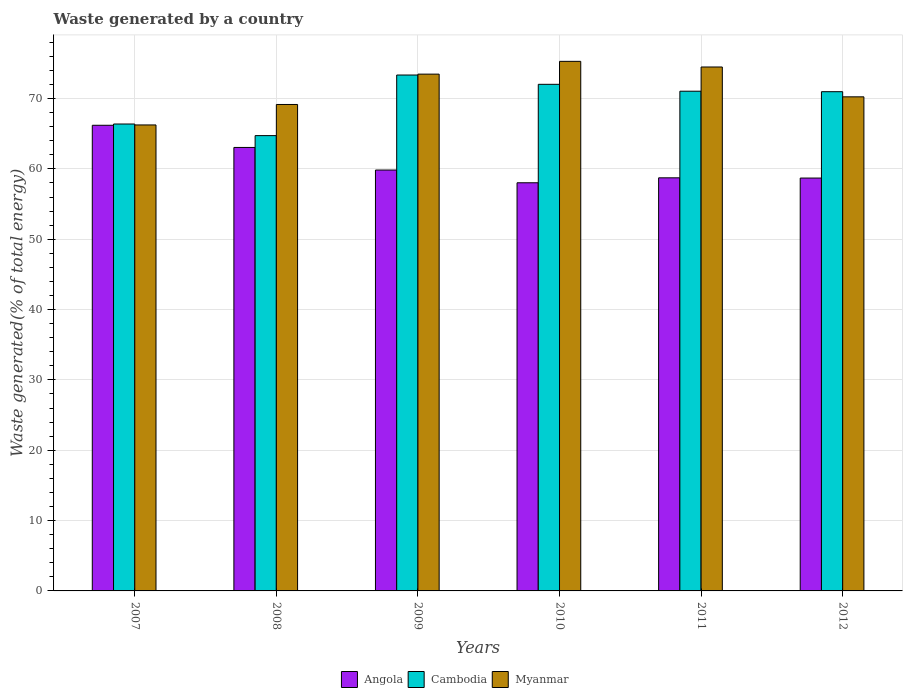Are the number of bars per tick equal to the number of legend labels?
Offer a very short reply. Yes. How many bars are there on the 3rd tick from the left?
Your response must be concise. 3. How many bars are there on the 3rd tick from the right?
Your answer should be compact. 3. What is the total waste generated in Angola in 2009?
Your answer should be very brief. 59.84. Across all years, what is the maximum total waste generated in Cambodia?
Ensure brevity in your answer.  73.35. Across all years, what is the minimum total waste generated in Angola?
Your answer should be very brief. 58.03. What is the total total waste generated in Angola in the graph?
Your answer should be very brief. 364.56. What is the difference between the total waste generated in Angola in 2007 and that in 2011?
Offer a very short reply. 7.47. What is the difference between the total waste generated in Myanmar in 2010 and the total waste generated in Angola in 2012?
Offer a very short reply. 16.59. What is the average total waste generated in Myanmar per year?
Provide a succinct answer. 71.49. In the year 2011, what is the difference between the total waste generated in Cambodia and total waste generated in Angola?
Your answer should be very brief. 12.31. What is the ratio of the total waste generated in Cambodia in 2010 to that in 2012?
Give a very brief answer. 1.01. What is the difference between the highest and the second highest total waste generated in Cambodia?
Your response must be concise. 1.32. What is the difference between the highest and the lowest total waste generated in Cambodia?
Your response must be concise. 8.62. In how many years, is the total waste generated in Angola greater than the average total waste generated in Angola taken over all years?
Provide a succinct answer. 2. What does the 3rd bar from the left in 2009 represents?
Offer a very short reply. Myanmar. What does the 3rd bar from the right in 2009 represents?
Offer a terse response. Angola. Is it the case that in every year, the sum of the total waste generated in Myanmar and total waste generated in Angola is greater than the total waste generated in Cambodia?
Make the answer very short. Yes. How many bars are there?
Offer a very short reply. 18. What is the difference between two consecutive major ticks on the Y-axis?
Keep it short and to the point. 10. Are the values on the major ticks of Y-axis written in scientific E-notation?
Your response must be concise. No. Does the graph contain grids?
Make the answer very short. Yes. What is the title of the graph?
Make the answer very short. Waste generated by a country. What is the label or title of the Y-axis?
Ensure brevity in your answer.  Waste generated(% of total energy). What is the Waste generated(% of total energy) in Angola in 2007?
Make the answer very short. 66.2. What is the Waste generated(% of total energy) of Cambodia in 2007?
Give a very brief answer. 66.38. What is the Waste generated(% of total energy) of Myanmar in 2007?
Make the answer very short. 66.25. What is the Waste generated(% of total energy) of Angola in 2008?
Offer a very short reply. 63.05. What is the Waste generated(% of total energy) in Cambodia in 2008?
Your answer should be compact. 64.73. What is the Waste generated(% of total energy) in Myanmar in 2008?
Give a very brief answer. 69.16. What is the Waste generated(% of total energy) in Angola in 2009?
Keep it short and to the point. 59.84. What is the Waste generated(% of total energy) in Cambodia in 2009?
Ensure brevity in your answer.  73.35. What is the Waste generated(% of total energy) in Myanmar in 2009?
Provide a succinct answer. 73.47. What is the Waste generated(% of total energy) of Angola in 2010?
Ensure brevity in your answer.  58.03. What is the Waste generated(% of total energy) of Cambodia in 2010?
Make the answer very short. 72.03. What is the Waste generated(% of total energy) in Myanmar in 2010?
Make the answer very short. 75.29. What is the Waste generated(% of total energy) in Angola in 2011?
Provide a succinct answer. 58.73. What is the Waste generated(% of total energy) of Cambodia in 2011?
Your response must be concise. 71.05. What is the Waste generated(% of total energy) of Myanmar in 2011?
Ensure brevity in your answer.  74.49. What is the Waste generated(% of total energy) in Angola in 2012?
Your answer should be very brief. 58.7. What is the Waste generated(% of total energy) of Cambodia in 2012?
Provide a short and direct response. 70.98. What is the Waste generated(% of total energy) of Myanmar in 2012?
Your answer should be very brief. 70.25. Across all years, what is the maximum Waste generated(% of total energy) of Angola?
Provide a short and direct response. 66.2. Across all years, what is the maximum Waste generated(% of total energy) in Cambodia?
Provide a succinct answer. 73.35. Across all years, what is the maximum Waste generated(% of total energy) of Myanmar?
Keep it short and to the point. 75.29. Across all years, what is the minimum Waste generated(% of total energy) of Angola?
Your answer should be very brief. 58.03. Across all years, what is the minimum Waste generated(% of total energy) of Cambodia?
Make the answer very short. 64.73. Across all years, what is the minimum Waste generated(% of total energy) of Myanmar?
Keep it short and to the point. 66.25. What is the total Waste generated(% of total energy) of Angola in the graph?
Your answer should be compact. 364.56. What is the total Waste generated(% of total energy) in Cambodia in the graph?
Your response must be concise. 418.52. What is the total Waste generated(% of total energy) in Myanmar in the graph?
Offer a terse response. 428.91. What is the difference between the Waste generated(% of total energy) in Angola in 2007 and that in 2008?
Make the answer very short. 3.15. What is the difference between the Waste generated(% of total energy) of Cambodia in 2007 and that in 2008?
Make the answer very short. 1.65. What is the difference between the Waste generated(% of total energy) of Myanmar in 2007 and that in 2008?
Ensure brevity in your answer.  -2.91. What is the difference between the Waste generated(% of total energy) of Angola in 2007 and that in 2009?
Provide a succinct answer. 6.37. What is the difference between the Waste generated(% of total energy) of Cambodia in 2007 and that in 2009?
Give a very brief answer. -6.96. What is the difference between the Waste generated(% of total energy) in Myanmar in 2007 and that in 2009?
Give a very brief answer. -7.22. What is the difference between the Waste generated(% of total energy) of Angola in 2007 and that in 2010?
Give a very brief answer. 8.18. What is the difference between the Waste generated(% of total energy) of Cambodia in 2007 and that in 2010?
Your answer should be compact. -5.64. What is the difference between the Waste generated(% of total energy) of Myanmar in 2007 and that in 2010?
Your answer should be compact. -9.04. What is the difference between the Waste generated(% of total energy) of Angola in 2007 and that in 2011?
Provide a succinct answer. 7.47. What is the difference between the Waste generated(% of total energy) in Cambodia in 2007 and that in 2011?
Provide a succinct answer. -4.66. What is the difference between the Waste generated(% of total energy) of Myanmar in 2007 and that in 2011?
Your response must be concise. -8.24. What is the difference between the Waste generated(% of total energy) of Angola in 2007 and that in 2012?
Offer a very short reply. 7.51. What is the difference between the Waste generated(% of total energy) in Cambodia in 2007 and that in 2012?
Ensure brevity in your answer.  -4.59. What is the difference between the Waste generated(% of total energy) of Myanmar in 2007 and that in 2012?
Offer a very short reply. -4. What is the difference between the Waste generated(% of total energy) in Angola in 2008 and that in 2009?
Ensure brevity in your answer.  3.21. What is the difference between the Waste generated(% of total energy) of Cambodia in 2008 and that in 2009?
Make the answer very short. -8.62. What is the difference between the Waste generated(% of total energy) of Myanmar in 2008 and that in 2009?
Give a very brief answer. -4.31. What is the difference between the Waste generated(% of total energy) of Angola in 2008 and that in 2010?
Your answer should be compact. 5.02. What is the difference between the Waste generated(% of total energy) in Cambodia in 2008 and that in 2010?
Make the answer very short. -7.3. What is the difference between the Waste generated(% of total energy) in Myanmar in 2008 and that in 2010?
Keep it short and to the point. -6.13. What is the difference between the Waste generated(% of total energy) of Angola in 2008 and that in 2011?
Provide a short and direct response. 4.32. What is the difference between the Waste generated(% of total energy) in Cambodia in 2008 and that in 2011?
Offer a very short reply. -6.32. What is the difference between the Waste generated(% of total energy) of Myanmar in 2008 and that in 2011?
Provide a short and direct response. -5.33. What is the difference between the Waste generated(% of total energy) of Angola in 2008 and that in 2012?
Give a very brief answer. 4.35. What is the difference between the Waste generated(% of total energy) in Cambodia in 2008 and that in 2012?
Your answer should be compact. -6.25. What is the difference between the Waste generated(% of total energy) in Myanmar in 2008 and that in 2012?
Offer a very short reply. -1.09. What is the difference between the Waste generated(% of total energy) in Angola in 2009 and that in 2010?
Give a very brief answer. 1.81. What is the difference between the Waste generated(% of total energy) of Cambodia in 2009 and that in 2010?
Offer a very short reply. 1.32. What is the difference between the Waste generated(% of total energy) in Myanmar in 2009 and that in 2010?
Your answer should be compact. -1.82. What is the difference between the Waste generated(% of total energy) of Angola in 2009 and that in 2011?
Provide a succinct answer. 1.11. What is the difference between the Waste generated(% of total energy) of Cambodia in 2009 and that in 2011?
Provide a short and direct response. 2.3. What is the difference between the Waste generated(% of total energy) in Myanmar in 2009 and that in 2011?
Give a very brief answer. -1.01. What is the difference between the Waste generated(% of total energy) of Angola in 2009 and that in 2012?
Make the answer very short. 1.14. What is the difference between the Waste generated(% of total energy) in Cambodia in 2009 and that in 2012?
Provide a succinct answer. 2.37. What is the difference between the Waste generated(% of total energy) in Myanmar in 2009 and that in 2012?
Provide a succinct answer. 3.23. What is the difference between the Waste generated(% of total energy) in Angola in 2010 and that in 2011?
Your response must be concise. -0.7. What is the difference between the Waste generated(% of total energy) of Cambodia in 2010 and that in 2011?
Ensure brevity in your answer.  0.98. What is the difference between the Waste generated(% of total energy) in Myanmar in 2010 and that in 2011?
Make the answer very short. 0.8. What is the difference between the Waste generated(% of total energy) in Angola in 2010 and that in 2012?
Provide a short and direct response. -0.67. What is the difference between the Waste generated(% of total energy) in Cambodia in 2010 and that in 2012?
Provide a succinct answer. 1.05. What is the difference between the Waste generated(% of total energy) in Myanmar in 2010 and that in 2012?
Your answer should be very brief. 5.05. What is the difference between the Waste generated(% of total energy) in Angola in 2011 and that in 2012?
Ensure brevity in your answer.  0.03. What is the difference between the Waste generated(% of total energy) in Cambodia in 2011 and that in 2012?
Ensure brevity in your answer.  0.07. What is the difference between the Waste generated(% of total energy) of Myanmar in 2011 and that in 2012?
Your response must be concise. 4.24. What is the difference between the Waste generated(% of total energy) of Angola in 2007 and the Waste generated(% of total energy) of Cambodia in 2008?
Your answer should be compact. 1.47. What is the difference between the Waste generated(% of total energy) of Angola in 2007 and the Waste generated(% of total energy) of Myanmar in 2008?
Make the answer very short. -2.96. What is the difference between the Waste generated(% of total energy) of Cambodia in 2007 and the Waste generated(% of total energy) of Myanmar in 2008?
Make the answer very short. -2.78. What is the difference between the Waste generated(% of total energy) of Angola in 2007 and the Waste generated(% of total energy) of Cambodia in 2009?
Give a very brief answer. -7.14. What is the difference between the Waste generated(% of total energy) in Angola in 2007 and the Waste generated(% of total energy) in Myanmar in 2009?
Your response must be concise. -7.27. What is the difference between the Waste generated(% of total energy) in Cambodia in 2007 and the Waste generated(% of total energy) in Myanmar in 2009?
Your response must be concise. -7.09. What is the difference between the Waste generated(% of total energy) of Angola in 2007 and the Waste generated(% of total energy) of Cambodia in 2010?
Your answer should be very brief. -5.82. What is the difference between the Waste generated(% of total energy) in Angola in 2007 and the Waste generated(% of total energy) in Myanmar in 2010?
Your answer should be very brief. -9.09. What is the difference between the Waste generated(% of total energy) in Cambodia in 2007 and the Waste generated(% of total energy) in Myanmar in 2010?
Give a very brief answer. -8.91. What is the difference between the Waste generated(% of total energy) in Angola in 2007 and the Waste generated(% of total energy) in Cambodia in 2011?
Make the answer very short. -4.84. What is the difference between the Waste generated(% of total energy) in Angola in 2007 and the Waste generated(% of total energy) in Myanmar in 2011?
Give a very brief answer. -8.28. What is the difference between the Waste generated(% of total energy) of Cambodia in 2007 and the Waste generated(% of total energy) of Myanmar in 2011?
Provide a short and direct response. -8.11. What is the difference between the Waste generated(% of total energy) in Angola in 2007 and the Waste generated(% of total energy) in Cambodia in 2012?
Offer a very short reply. -4.77. What is the difference between the Waste generated(% of total energy) in Angola in 2007 and the Waste generated(% of total energy) in Myanmar in 2012?
Offer a terse response. -4.04. What is the difference between the Waste generated(% of total energy) in Cambodia in 2007 and the Waste generated(% of total energy) in Myanmar in 2012?
Offer a very short reply. -3.86. What is the difference between the Waste generated(% of total energy) in Angola in 2008 and the Waste generated(% of total energy) in Cambodia in 2009?
Give a very brief answer. -10.3. What is the difference between the Waste generated(% of total energy) in Angola in 2008 and the Waste generated(% of total energy) in Myanmar in 2009?
Ensure brevity in your answer.  -10.42. What is the difference between the Waste generated(% of total energy) of Cambodia in 2008 and the Waste generated(% of total energy) of Myanmar in 2009?
Provide a succinct answer. -8.74. What is the difference between the Waste generated(% of total energy) in Angola in 2008 and the Waste generated(% of total energy) in Cambodia in 2010?
Offer a very short reply. -8.98. What is the difference between the Waste generated(% of total energy) of Angola in 2008 and the Waste generated(% of total energy) of Myanmar in 2010?
Ensure brevity in your answer.  -12.24. What is the difference between the Waste generated(% of total energy) of Cambodia in 2008 and the Waste generated(% of total energy) of Myanmar in 2010?
Offer a terse response. -10.56. What is the difference between the Waste generated(% of total energy) in Angola in 2008 and the Waste generated(% of total energy) in Cambodia in 2011?
Provide a short and direct response. -8. What is the difference between the Waste generated(% of total energy) of Angola in 2008 and the Waste generated(% of total energy) of Myanmar in 2011?
Keep it short and to the point. -11.44. What is the difference between the Waste generated(% of total energy) of Cambodia in 2008 and the Waste generated(% of total energy) of Myanmar in 2011?
Give a very brief answer. -9.76. What is the difference between the Waste generated(% of total energy) in Angola in 2008 and the Waste generated(% of total energy) in Cambodia in 2012?
Ensure brevity in your answer.  -7.93. What is the difference between the Waste generated(% of total energy) of Angola in 2008 and the Waste generated(% of total energy) of Myanmar in 2012?
Your response must be concise. -7.2. What is the difference between the Waste generated(% of total energy) in Cambodia in 2008 and the Waste generated(% of total energy) in Myanmar in 2012?
Your response must be concise. -5.51. What is the difference between the Waste generated(% of total energy) of Angola in 2009 and the Waste generated(% of total energy) of Cambodia in 2010?
Provide a short and direct response. -12.19. What is the difference between the Waste generated(% of total energy) in Angola in 2009 and the Waste generated(% of total energy) in Myanmar in 2010?
Provide a succinct answer. -15.45. What is the difference between the Waste generated(% of total energy) in Cambodia in 2009 and the Waste generated(% of total energy) in Myanmar in 2010?
Offer a very short reply. -1.94. What is the difference between the Waste generated(% of total energy) of Angola in 2009 and the Waste generated(% of total energy) of Cambodia in 2011?
Provide a short and direct response. -11.21. What is the difference between the Waste generated(% of total energy) in Angola in 2009 and the Waste generated(% of total energy) in Myanmar in 2011?
Keep it short and to the point. -14.65. What is the difference between the Waste generated(% of total energy) in Cambodia in 2009 and the Waste generated(% of total energy) in Myanmar in 2011?
Ensure brevity in your answer.  -1.14. What is the difference between the Waste generated(% of total energy) of Angola in 2009 and the Waste generated(% of total energy) of Cambodia in 2012?
Your answer should be compact. -11.14. What is the difference between the Waste generated(% of total energy) of Angola in 2009 and the Waste generated(% of total energy) of Myanmar in 2012?
Give a very brief answer. -10.41. What is the difference between the Waste generated(% of total energy) in Cambodia in 2009 and the Waste generated(% of total energy) in Myanmar in 2012?
Keep it short and to the point. 3.1. What is the difference between the Waste generated(% of total energy) in Angola in 2010 and the Waste generated(% of total energy) in Cambodia in 2011?
Provide a succinct answer. -13.02. What is the difference between the Waste generated(% of total energy) in Angola in 2010 and the Waste generated(% of total energy) in Myanmar in 2011?
Make the answer very short. -16.46. What is the difference between the Waste generated(% of total energy) in Cambodia in 2010 and the Waste generated(% of total energy) in Myanmar in 2011?
Your answer should be very brief. -2.46. What is the difference between the Waste generated(% of total energy) in Angola in 2010 and the Waste generated(% of total energy) in Cambodia in 2012?
Your response must be concise. -12.95. What is the difference between the Waste generated(% of total energy) of Angola in 2010 and the Waste generated(% of total energy) of Myanmar in 2012?
Make the answer very short. -12.22. What is the difference between the Waste generated(% of total energy) of Cambodia in 2010 and the Waste generated(% of total energy) of Myanmar in 2012?
Your response must be concise. 1.78. What is the difference between the Waste generated(% of total energy) of Angola in 2011 and the Waste generated(% of total energy) of Cambodia in 2012?
Offer a terse response. -12.25. What is the difference between the Waste generated(% of total energy) of Angola in 2011 and the Waste generated(% of total energy) of Myanmar in 2012?
Provide a succinct answer. -11.51. What is the difference between the Waste generated(% of total energy) in Cambodia in 2011 and the Waste generated(% of total energy) in Myanmar in 2012?
Your answer should be compact. 0.8. What is the average Waste generated(% of total energy) of Angola per year?
Ensure brevity in your answer.  60.76. What is the average Waste generated(% of total energy) of Cambodia per year?
Make the answer very short. 69.75. What is the average Waste generated(% of total energy) of Myanmar per year?
Make the answer very short. 71.49. In the year 2007, what is the difference between the Waste generated(% of total energy) in Angola and Waste generated(% of total energy) in Cambodia?
Your answer should be very brief. -0.18. In the year 2007, what is the difference between the Waste generated(% of total energy) of Angola and Waste generated(% of total energy) of Myanmar?
Offer a terse response. -0.05. In the year 2007, what is the difference between the Waste generated(% of total energy) in Cambodia and Waste generated(% of total energy) in Myanmar?
Keep it short and to the point. 0.13. In the year 2008, what is the difference between the Waste generated(% of total energy) in Angola and Waste generated(% of total energy) in Cambodia?
Give a very brief answer. -1.68. In the year 2008, what is the difference between the Waste generated(% of total energy) of Angola and Waste generated(% of total energy) of Myanmar?
Ensure brevity in your answer.  -6.11. In the year 2008, what is the difference between the Waste generated(% of total energy) of Cambodia and Waste generated(% of total energy) of Myanmar?
Keep it short and to the point. -4.43. In the year 2009, what is the difference between the Waste generated(% of total energy) in Angola and Waste generated(% of total energy) in Cambodia?
Give a very brief answer. -13.51. In the year 2009, what is the difference between the Waste generated(% of total energy) in Angola and Waste generated(% of total energy) in Myanmar?
Make the answer very short. -13.64. In the year 2009, what is the difference between the Waste generated(% of total energy) of Cambodia and Waste generated(% of total energy) of Myanmar?
Your answer should be compact. -0.13. In the year 2010, what is the difference between the Waste generated(% of total energy) in Angola and Waste generated(% of total energy) in Cambodia?
Provide a succinct answer. -14. In the year 2010, what is the difference between the Waste generated(% of total energy) in Angola and Waste generated(% of total energy) in Myanmar?
Your answer should be very brief. -17.26. In the year 2010, what is the difference between the Waste generated(% of total energy) in Cambodia and Waste generated(% of total energy) in Myanmar?
Give a very brief answer. -3.26. In the year 2011, what is the difference between the Waste generated(% of total energy) in Angola and Waste generated(% of total energy) in Cambodia?
Make the answer very short. -12.31. In the year 2011, what is the difference between the Waste generated(% of total energy) of Angola and Waste generated(% of total energy) of Myanmar?
Provide a short and direct response. -15.76. In the year 2011, what is the difference between the Waste generated(% of total energy) in Cambodia and Waste generated(% of total energy) in Myanmar?
Give a very brief answer. -3.44. In the year 2012, what is the difference between the Waste generated(% of total energy) of Angola and Waste generated(% of total energy) of Cambodia?
Offer a very short reply. -12.28. In the year 2012, what is the difference between the Waste generated(% of total energy) of Angola and Waste generated(% of total energy) of Myanmar?
Offer a terse response. -11.55. In the year 2012, what is the difference between the Waste generated(% of total energy) of Cambodia and Waste generated(% of total energy) of Myanmar?
Keep it short and to the point. 0.73. What is the ratio of the Waste generated(% of total energy) of Cambodia in 2007 to that in 2008?
Provide a succinct answer. 1.03. What is the ratio of the Waste generated(% of total energy) in Myanmar in 2007 to that in 2008?
Provide a short and direct response. 0.96. What is the ratio of the Waste generated(% of total energy) of Angola in 2007 to that in 2009?
Offer a terse response. 1.11. What is the ratio of the Waste generated(% of total energy) of Cambodia in 2007 to that in 2009?
Your answer should be compact. 0.91. What is the ratio of the Waste generated(% of total energy) of Myanmar in 2007 to that in 2009?
Keep it short and to the point. 0.9. What is the ratio of the Waste generated(% of total energy) of Angola in 2007 to that in 2010?
Offer a very short reply. 1.14. What is the ratio of the Waste generated(% of total energy) of Cambodia in 2007 to that in 2010?
Offer a very short reply. 0.92. What is the ratio of the Waste generated(% of total energy) in Myanmar in 2007 to that in 2010?
Offer a very short reply. 0.88. What is the ratio of the Waste generated(% of total energy) of Angola in 2007 to that in 2011?
Your answer should be compact. 1.13. What is the ratio of the Waste generated(% of total energy) in Cambodia in 2007 to that in 2011?
Make the answer very short. 0.93. What is the ratio of the Waste generated(% of total energy) in Myanmar in 2007 to that in 2011?
Keep it short and to the point. 0.89. What is the ratio of the Waste generated(% of total energy) of Angola in 2007 to that in 2012?
Ensure brevity in your answer.  1.13. What is the ratio of the Waste generated(% of total energy) in Cambodia in 2007 to that in 2012?
Keep it short and to the point. 0.94. What is the ratio of the Waste generated(% of total energy) of Myanmar in 2007 to that in 2012?
Give a very brief answer. 0.94. What is the ratio of the Waste generated(% of total energy) of Angola in 2008 to that in 2009?
Ensure brevity in your answer.  1.05. What is the ratio of the Waste generated(% of total energy) in Cambodia in 2008 to that in 2009?
Ensure brevity in your answer.  0.88. What is the ratio of the Waste generated(% of total energy) of Myanmar in 2008 to that in 2009?
Provide a short and direct response. 0.94. What is the ratio of the Waste generated(% of total energy) in Angola in 2008 to that in 2010?
Offer a terse response. 1.09. What is the ratio of the Waste generated(% of total energy) in Cambodia in 2008 to that in 2010?
Provide a short and direct response. 0.9. What is the ratio of the Waste generated(% of total energy) of Myanmar in 2008 to that in 2010?
Offer a terse response. 0.92. What is the ratio of the Waste generated(% of total energy) of Angola in 2008 to that in 2011?
Your answer should be very brief. 1.07. What is the ratio of the Waste generated(% of total energy) of Cambodia in 2008 to that in 2011?
Your answer should be very brief. 0.91. What is the ratio of the Waste generated(% of total energy) in Myanmar in 2008 to that in 2011?
Offer a terse response. 0.93. What is the ratio of the Waste generated(% of total energy) of Angola in 2008 to that in 2012?
Make the answer very short. 1.07. What is the ratio of the Waste generated(% of total energy) of Cambodia in 2008 to that in 2012?
Offer a terse response. 0.91. What is the ratio of the Waste generated(% of total energy) of Myanmar in 2008 to that in 2012?
Provide a succinct answer. 0.98. What is the ratio of the Waste generated(% of total energy) in Angola in 2009 to that in 2010?
Give a very brief answer. 1.03. What is the ratio of the Waste generated(% of total energy) of Cambodia in 2009 to that in 2010?
Offer a very short reply. 1.02. What is the ratio of the Waste generated(% of total energy) of Myanmar in 2009 to that in 2010?
Offer a very short reply. 0.98. What is the ratio of the Waste generated(% of total energy) in Angola in 2009 to that in 2011?
Provide a succinct answer. 1.02. What is the ratio of the Waste generated(% of total energy) in Cambodia in 2009 to that in 2011?
Offer a very short reply. 1.03. What is the ratio of the Waste generated(% of total energy) of Myanmar in 2009 to that in 2011?
Offer a terse response. 0.99. What is the ratio of the Waste generated(% of total energy) in Angola in 2009 to that in 2012?
Make the answer very short. 1.02. What is the ratio of the Waste generated(% of total energy) of Cambodia in 2009 to that in 2012?
Your answer should be compact. 1.03. What is the ratio of the Waste generated(% of total energy) of Myanmar in 2009 to that in 2012?
Ensure brevity in your answer.  1.05. What is the ratio of the Waste generated(% of total energy) of Cambodia in 2010 to that in 2011?
Your answer should be compact. 1.01. What is the ratio of the Waste generated(% of total energy) in Myanmar in 2010 to that in 2011?
Offer a very short reply. 1.01. What is the ratio of the Waste generated(% of total energy) in Cambodia in 2010 to that in 2012?
Keep it short and to the point. 1.01. What is the ratio of the Waste generated(% of total energy) in Myanmar in 2010 to that in 2012?
Your response must be concise. 1.07. What is the ratio of the Waste generated(% of total energy) in Angola in 2011 to that in 2012?
Your response must be concise. 1. What is the ratio of the Waste generated(% of total energy) of Myanmar in 2011 to that in 2012?
Your answer should be compact. 1.06. What is the difference between the highest and the second highest Waste generated(% of total energy) in Angola?
Ensure brevity in your answer.  3.15. What is the difference between the highest and the second highest Waste generated(% of total energy) in Cambodia?
Ensure brevity in your answer.  1.32. What is the difference between the highest and the second highest Waste generated(% of total energy) in Myanmar?
Give a very brief answer. 0.8. What is the difference between the highest and the lowest Waste generated(% of total energy) of Angola?
Your answer should be very brief. 8.18. What is the difference between the highest and the lowest Waste generated(% of total energy) of Cambodia?
Your answer should be very brief. 8.62. What is the difference between the highest and the lowest Waste generated(% of total energy) in Myanmar?
Offer a terse response. 9.04. 